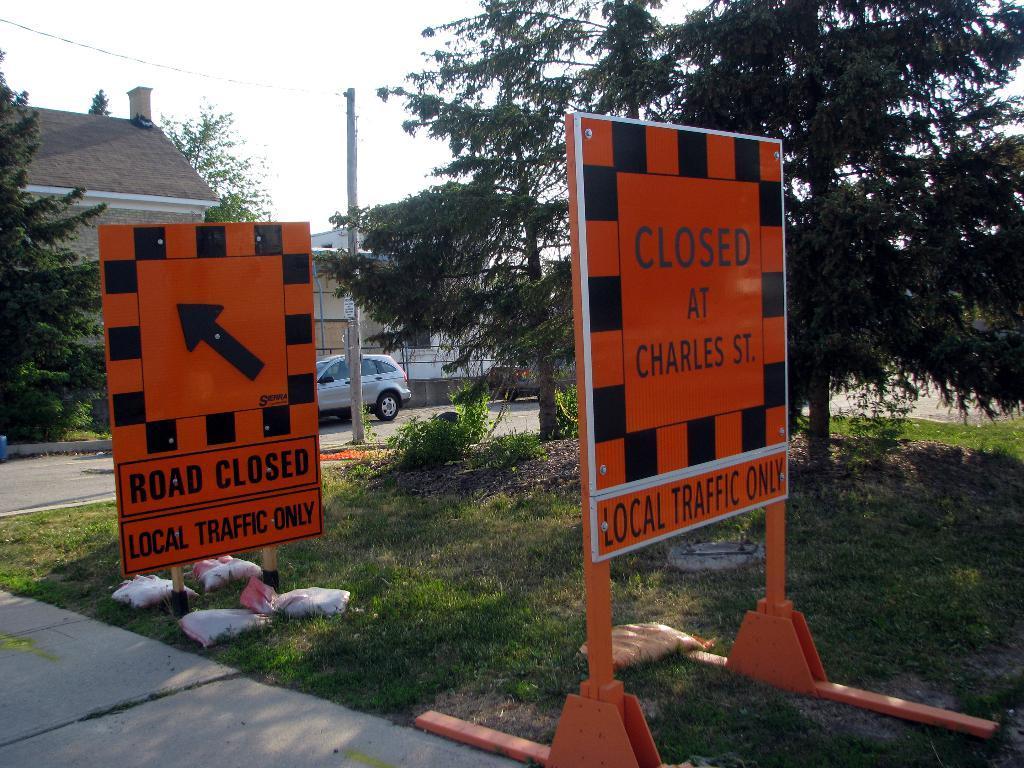Could you give a brief overview of what you see in this image? In this image there is a name sign board on the surface of the grass, behind the board there are trees and buildings and there is a car parked on the road. 